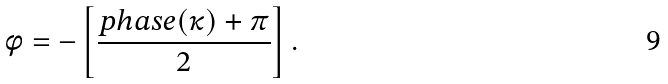<formula> <loc_0><loc_0><loc_500><loc_500>\phi = - \left [ \frac { p h a s e ( \kappa ) + \pi } { 2 } \right ] .</formula> 